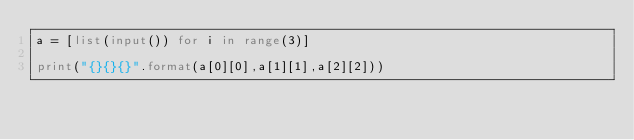Convert code to text. <code><loc_0><loc_0><loc_500><loc_500><_Python_>a = [list(input()) for i in range(3)]

print("{}{}{}".format(a[0][0],a[1][1],a[2][2]))</code> 